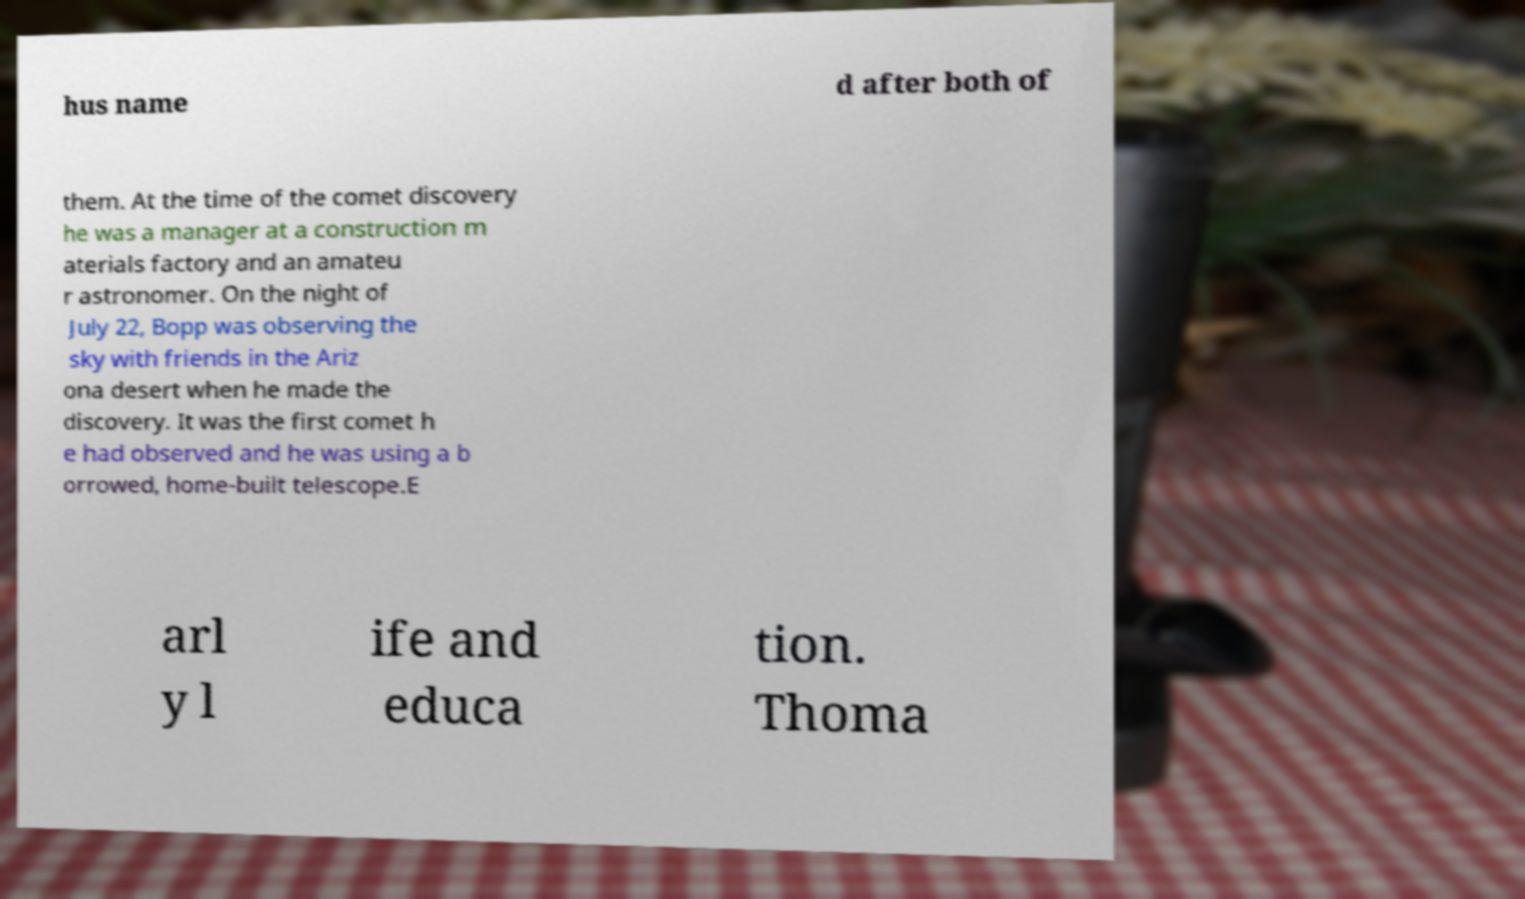Please identify and transcribe the text found in this image. hus name d after both of them. At the time of the comet discovery he was a manager at a construction m aterials factory and an amateu r astronomer. On the night of July 22, Bopp was observing the sky with friends in the Ariz ona desert when he made the discovery. It was the first comet h e had observed and he was using a b orrowed, home-built telescope.E arl y l ife and educa tion. Thoma 